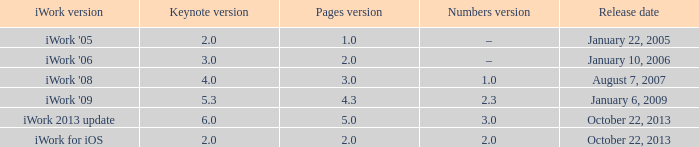What's the most recent keynote edition of version None. Can you give me this table as a dict? {'header': ['iWork version', 'Keynote version', 'Pages version', 'Numbers version', 'Release date'], 'rows': [["iWork '05", '2.0', '1.0', '–', 'January 22, 2005'], ["iWork '06", '3.0', '2.0', '–', 'January 10, 2006'], ["iWork '08", '4.0', '3.0', '1.0', 'August 7, 2007'], ["iWork '09", '5.3', '4.3', '2.3', 'January 6, 2009'], ['iWork 2013 update', '6.0', '5.0', '3.0', 'October 22, 2013'], ['iWork for iOS', '2.0', '2.0', '2.0', 'October 22, 2013']]} 